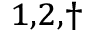<formula> <loc_0><loc_0><loc_500><loc_500>^ { 1 , 2 , \dagger }</formula> 